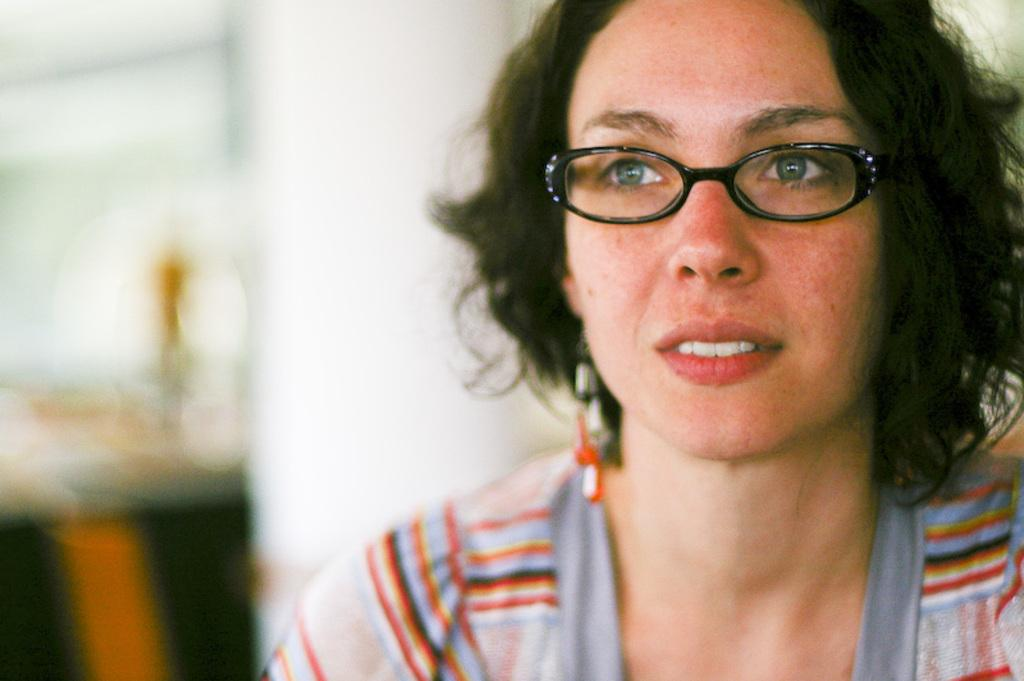Who is present in the image? There is a woman in the image. What accessory is the woman wearing? The woman is wearing glasses. What can be seen in the background of the image? There is a wall in the background of the image. What type of spark can be seen coming from the woman's glasses in the image? There is no spark visible in the image; the woman is simply wearing glasses. 